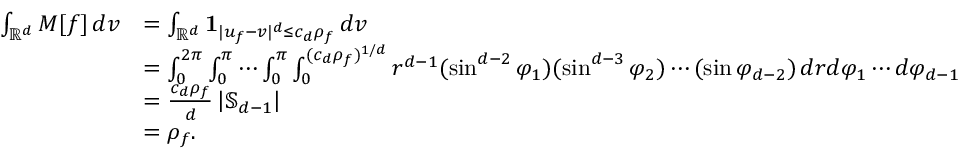<formula> <loc_0><loc_0><loc_500><loc_500>\begin{array} { r l } { \int _ { \mathbb { R } ^ { d } } M [ f ] \, d v } & { = \int _ { \mathbb { R } ^ { d } } 1 _ { | u _ { f } - v | ^ { d } \leq c _ { d } \rho _ { f } } \, d v } \\ & { = \int _ { 0 } ^ { 2 \pi } \int _ { 0 } ^ { \pi } \cdots \int _ { 0 } ^ { \pi } \int _ { 0 } ^ { ( c _ { d } \rho _ { f } ) ^ { 1 / d } } r ^ { d - 1 } ( \sin ^ { d - 2 } \varphi _ { 1 } ) ( \sin ^ { d - 3 } \varphi _ { 2 } ) \cdots ( \sin \varphi _ { d - 2 } ) \, d r d \varphi _ { 1 } \cdots d \varphi _ { d - 1 } } \\ & { = \frac { c _ { d } \rho _ { f } } { d } \left | \mathbb { S } _ { d - 1 } \right | } \\ & { = \rho _ { f } . } \end{array}</formula> 